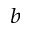<formula> <loc_0><loc_0><loc_500><loc_500>^ { b }</formula> 